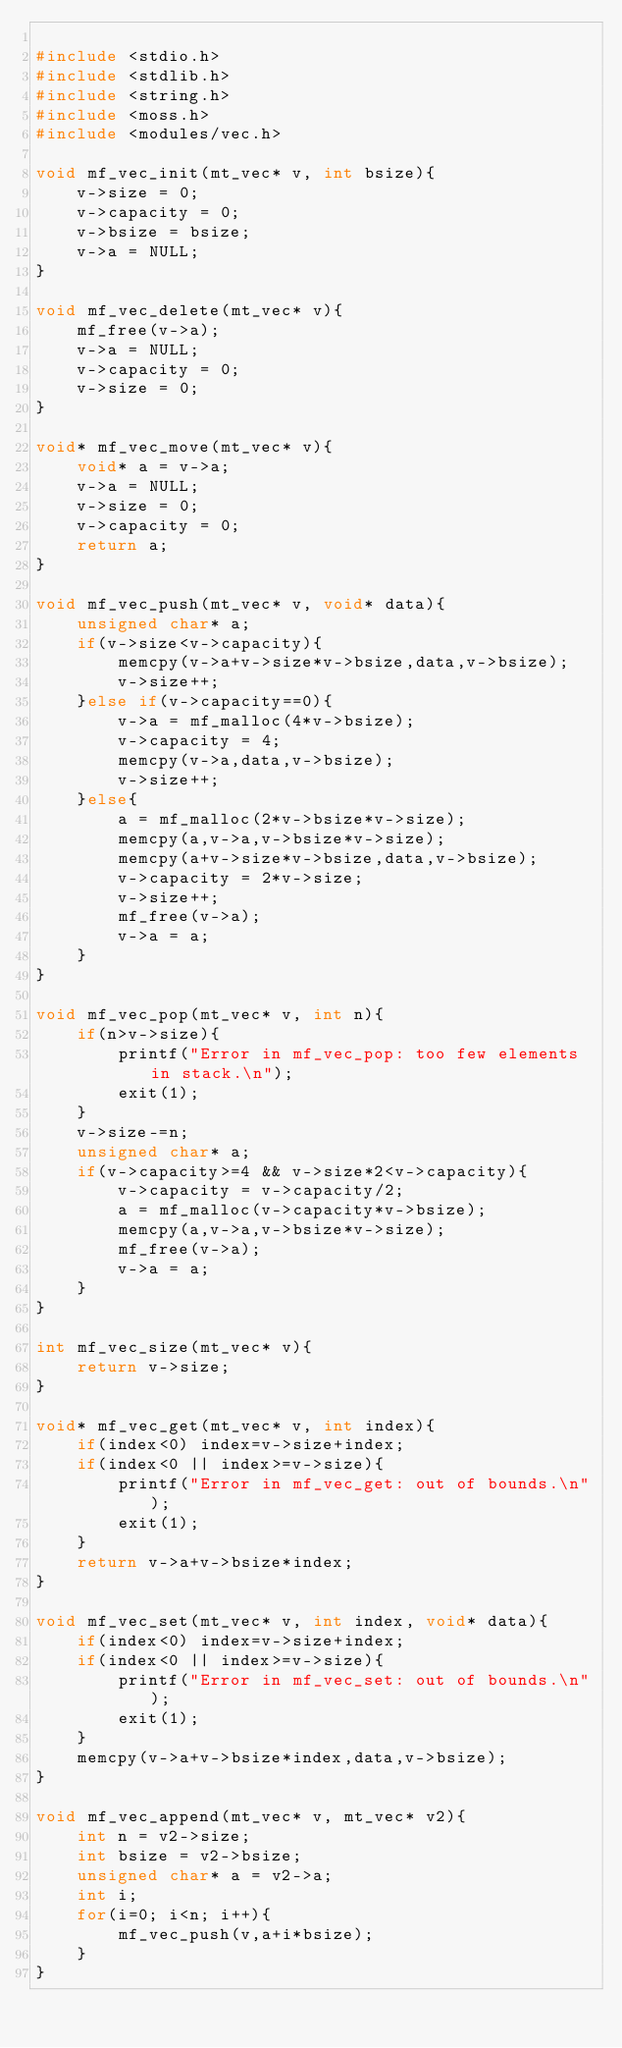<code> <loc_0><loc_0><loc_500><loc_500><_C_>
#include <stdio.h>
#include <stdlib.h>
#include <string.h>
#include <moss.h>
#include <modules/vec.h>

void mf_vec_init(mt_vec* v, int bsize){
    v->size = 0;
    v->capacity = 0;
    v->bsize = bsize;
    v->a = NULL;
}

void mf_vec_delete(mt_vec* v){
    mf_free(v->a);
    v->a = NULL;
    v->capacity = 0;
    v->size = 0;
}

void* mf_vec_move(mt_vec* v){
    void* a = v->a;
    v->a = NULL;
    v->size = 0;
    v->capacity = 0;
    return a;
}

void mf_vec_push(mt_vec* v, void* data){
    unsigned char* a;
    if(v->size<v->capacity){
        memcpy(v->a+v->size*v->bsize,data,v->bsize);
        v->size++;
    }else if(v->capacity==0){
        v->a = mf_malloc(4*v->bsize);
        v->capacity = 4;
        memcpy(v->a,data,v->bsize);
        v->size++;
    }else{
        a = mf_malloc(2*v->bsize*v->size);
        memcpy(a,v->a,v->bsize*v->size);
        memcpy(a+v->size*v->bsize,data,v->bsize);
        v->capacity = 2*v->size;
        v->size++;
        mf_free(v->a);
        v->a = a;
    }
}

void mf_vec_pop(mt_vec* v, int n){
    if(n>v->size){
        printf("Error in mf_vec_pop: too few elements in stack.\n");
        exit(1);
    }
    v->size-=n;
    unsigned char* a;
    if(v->capacity>=4 && v->size*2<v->capacity){
        v->capacity = v->capacity/2;
        a = mf_malloc(v->capacity*v->bsize);
        memcpy(a,v->a,v->bsize*v->size);
        mf_free(v->a);
        v->a = a;
    }
}

int mf_vec_size(mt_vec* v){
    return v->size;
}

void* mf_vec_get(mt_vec* v, int index){
    if(index<0) index=v->size+index;
    if(index<0 || index>=v->size){
        printf("Error in mf_vec_get: out of bounds.\n");
        exit(1);
    }
    return v->a+v->bsize*index;
}

void mf_vec_set(mt_vec* v, int index, void* data){
    if(index<0) index=v->size+index;
    if(index<0 || index>=v->size){
        printf("Error in mf_vec_set: out of bounds.\n");
        exit(1);
    }
    memcpy(v->a+v->bsize*index,data,v->bsize);
}

void mf_vec_append(mt_vec* v, mt_vec* v2){
    int n = v2->size;
    int bsize = v2->bsize;
    unsigned char* a = v2->a;
    int i;
    for(i=0; i<n; i++){
        mf_vec_push(v,a+i*bsize);
    }
}
</code> 